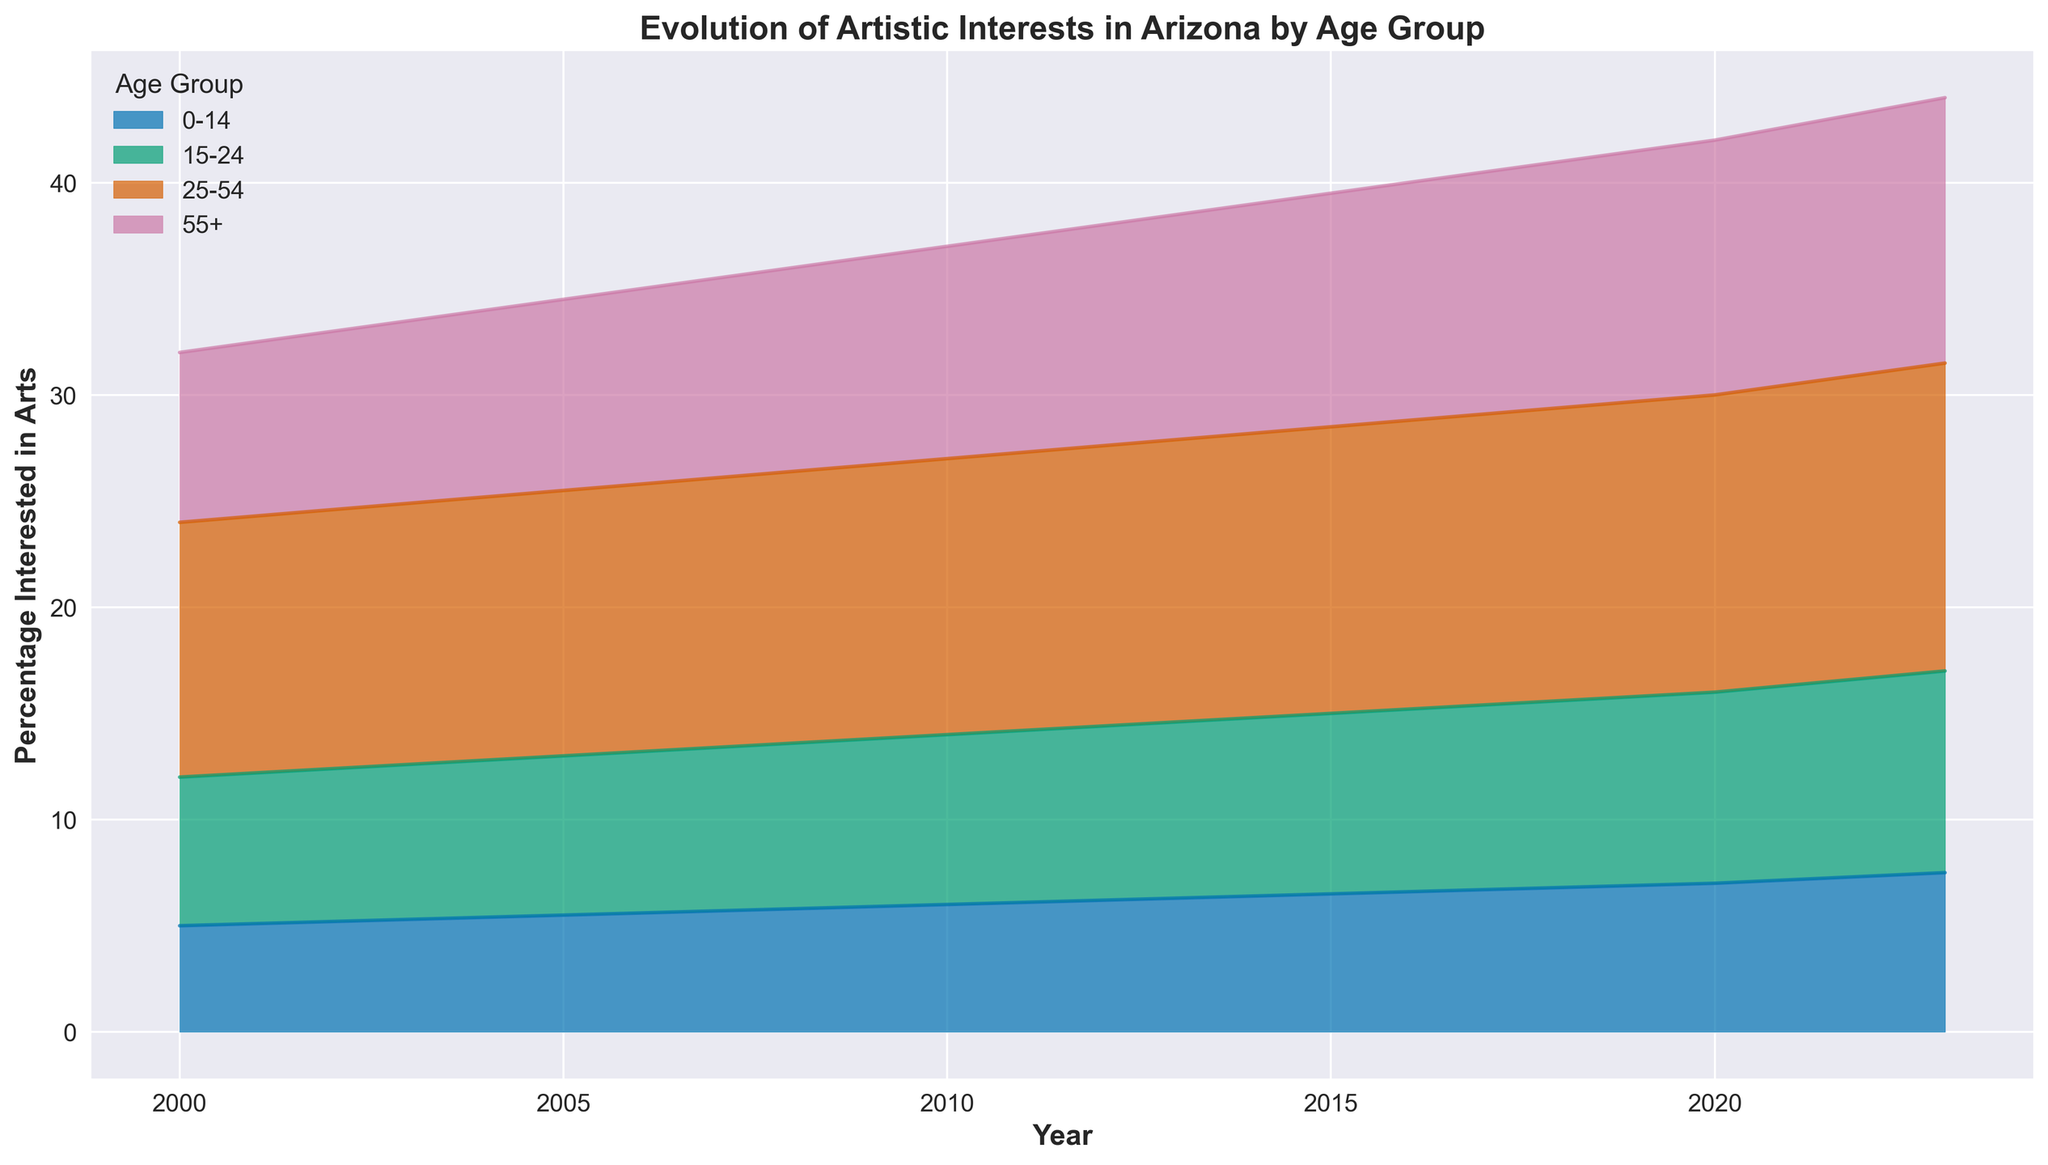What is the overall trend in artistic interests across all age groups from 2000 to 2023? The chart shows cumulative percentages for each age group over time. Observing the height of the areas stacked over the years, we see a steady increase in the overall interest in artistic activities from 2000 to 2023.
Answer: Increasing Which age group showed the highest percentage of artistic interest in 2023? By looking at the height of each area on top of the x-axis at 2023, the "25-54" age group's area is the largest, indicating the highest artistic interest percentage.
Answer: 25-54 Has the percentage of artistic interests in the "0-14" age group steadily increased, decreased, or fluctuated from 2000 to 2023? Observing the bottom-most area (representing "0-14"), we see that it has consistently grown from 5% in 2000 to 7.5% in 2023, showing a steady increase.
Answer: Steadily increased How does the artistic interest in the "55+" age group in 2023 compare to that in 2000? Comparing the two segments for the "55+" age group at 2000 (8%) and 2023 (12.5%), we see that the percentage has increased by 4.5%.
Answer: Increased Which year shows the steepest increase in artistic interests for the "15-24" age group? By reviewing the yearly changes, the "15-24" segment shows a noticeable rise between 2015 (8.5%) and 2020 (9%), making 2015-2020 the steepest increase.
Answer: 2015-2020 What's the combined artistic interest percentage for the age groups "0-14" and "15-24" in 2010? For 2010, we sum the percentages of the "0-14" (6%) and "15-24" (8%) groups, resulting in 14%.
Answer: 14% Which age group had the smallest change in artistic interest from 2000 to 2023? Calculating the change for each group: "0-14" (2.5%), "15-24" (2.5%), "25-54" (2.5%), and "55+" (4.5%), the smallest change is equal among "0-14", "15-24", and "25-54" with 2.5%.
Answer: 0-14, 15-24, 25-54 How much more percentage of the population in the "25-54" age group had an interest in arts in 2020 compared to 2005? Subtracting the "25-54" percentage in 2005 (12.5%) from the percentage in 2020 (14%), we get a difference of 1.5%.
Answer: 1.5% What is the general trend of artistic interests for the "25-54" age group from 2000 to 2023? Inspecting the middle part of the stacked areas across the years, we see the "25-54" group's segment consistently rising from 12% in 2000 to 14.5% in 2023.
Answer: Increasing 